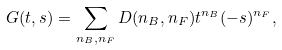Convert formula to latex. <formula><loc_0><loc_0><loc_500><loc_500>G ( t , s ) = \sum _ { n _ { B } , n _ { F } } D ( n _ { B } , n _ { F } ) t ^ { n _ { B } } ( - s ) ^ { n _ { F } } ,</formula> 